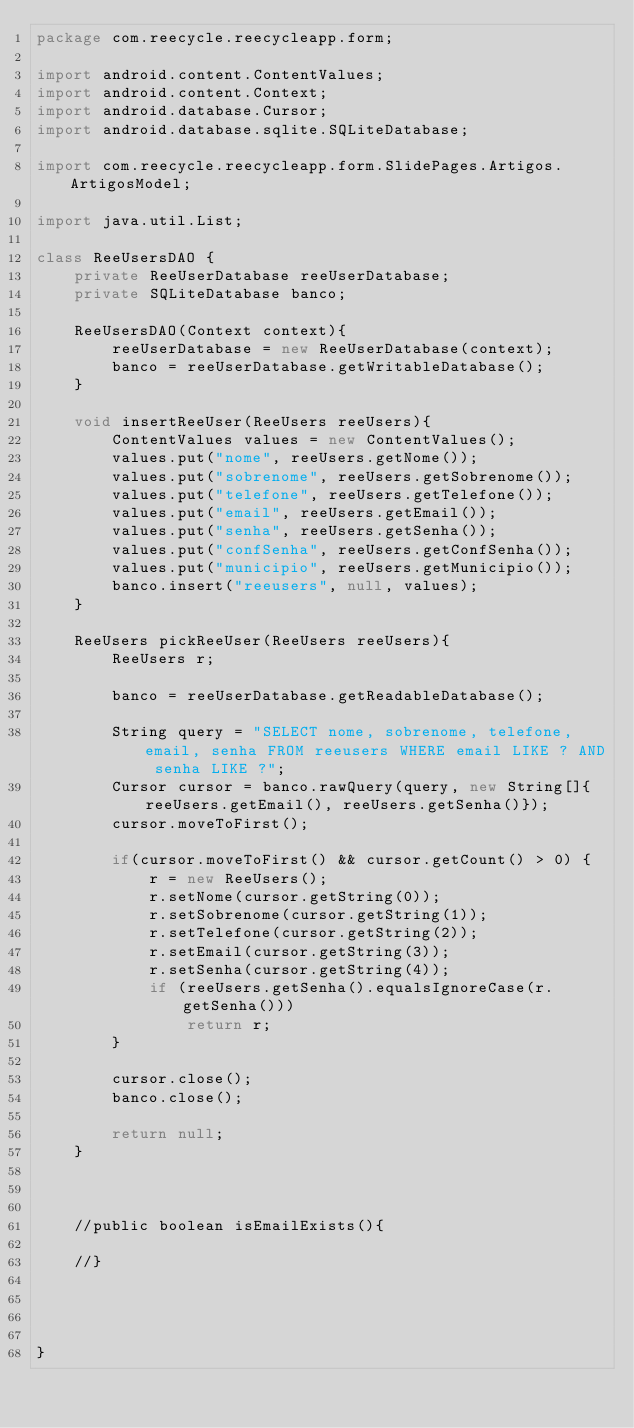Convert code to text. <code><loc_0><loc_0><loc_500><loc_500><_Java_>package com.reecycle.reecycleapp.form;

import android.content.ContentValues;
import android.content.Context;
import android.database.Cursor;
import android.database.sqlite.SQLiteDatabase;

import com.reecycle.reecycleapp.form.SlidePages.Artigos.ArtigosModel;

import java.util.List;

class ReeUsersDAO {
    private ReeUserDatabase reeUserDatabase;
    private SQLiteDatabase banco;

    ReeUsersDAO(Context context){
        reeUserDatabase = new ReeUserDatabase(context);
        banco = reeUserDatabase.getWritableDatabase();
    }

    void insertReeUser(ReeUsers reeUsers){
        ContentValues values = new ContentValues();
        values.put("nome", reeUsers.getNome());
        values.put("sobrenome", reeUsers.getSobrenome());
        values.put("telefone", reeUsers.getTelefone());
        values.put("email", reeUsers.getEmail());
        values.put("senha", reeUsers.getSenha());
        values.put("confSenha", reeUsers.getConfSenha());
        values.put("municipio", reeUsers.getMunicipio());
        banco.insert("reeusers", null, values);
    }

    ReeUsers pickReeUser(ReeUsers reeUsers){
        ReeUsers r;

        banco = reeUserDatabase.getReadableDatabase();

        String query = "SELECT nome, sobrenome, telefone, email, senha FROM reeusers WHERE email LIKE ? AND senha LIKE ?";
        Cursor cursor = banco.rawQuery(query, new String[]{reeUsers.getEmail(), reeUsers.getSenha()});
        cursor.moveToFirst();

        if(cursor.moveToFirst() && cursor.getCount() > 0) {
            r = new ReeUsers();
            r.setNome(cursor.getString(0));
            r.setSobrenome(cursor.getString(1));
            r.setTelefone(cursor.getString(2));
            r.setEmail(cursor.getString(3));
            r.setSenha(cursor.getString(4));
            if (reeUsers.getSenha().equalsIgnoreCase(r.getSenha()))
                return r;
        }

        cursor.close();
        banco.close();

        return null;
    }



    //public boolean isEmailExists(){

    //}




}
</code> 